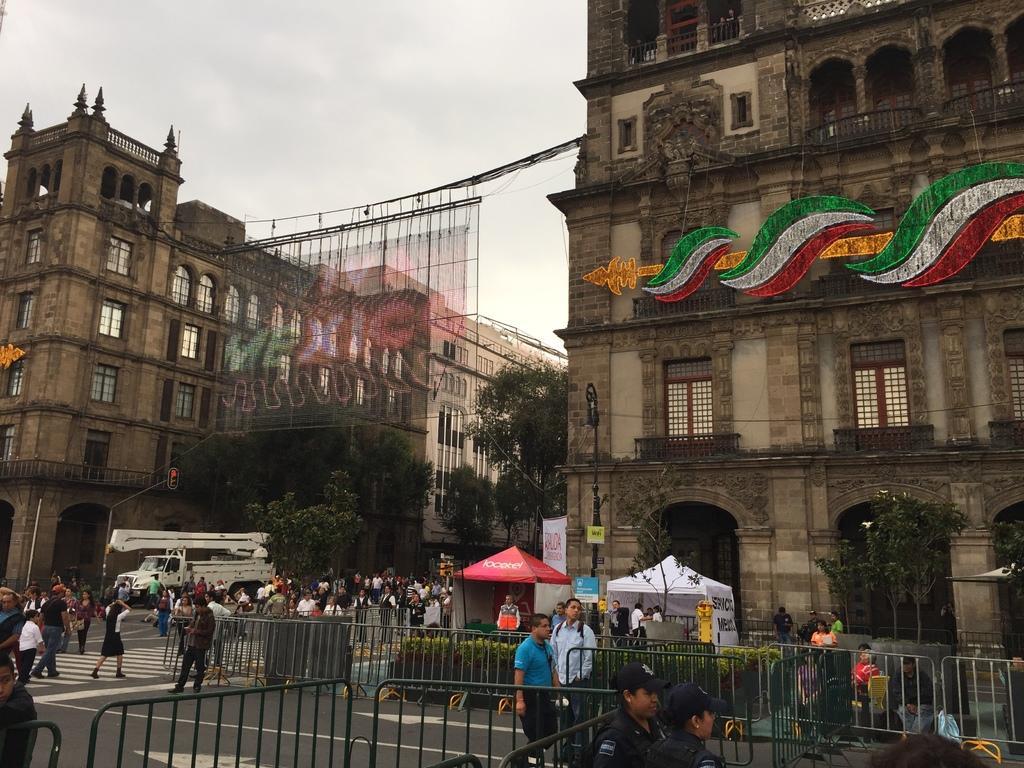Describe this image in one or two sentences. In this image we can see people, railings, plants, vehicle, tents, road, poles, trees, boards, and few objects. In the background there are buildings and sky. 